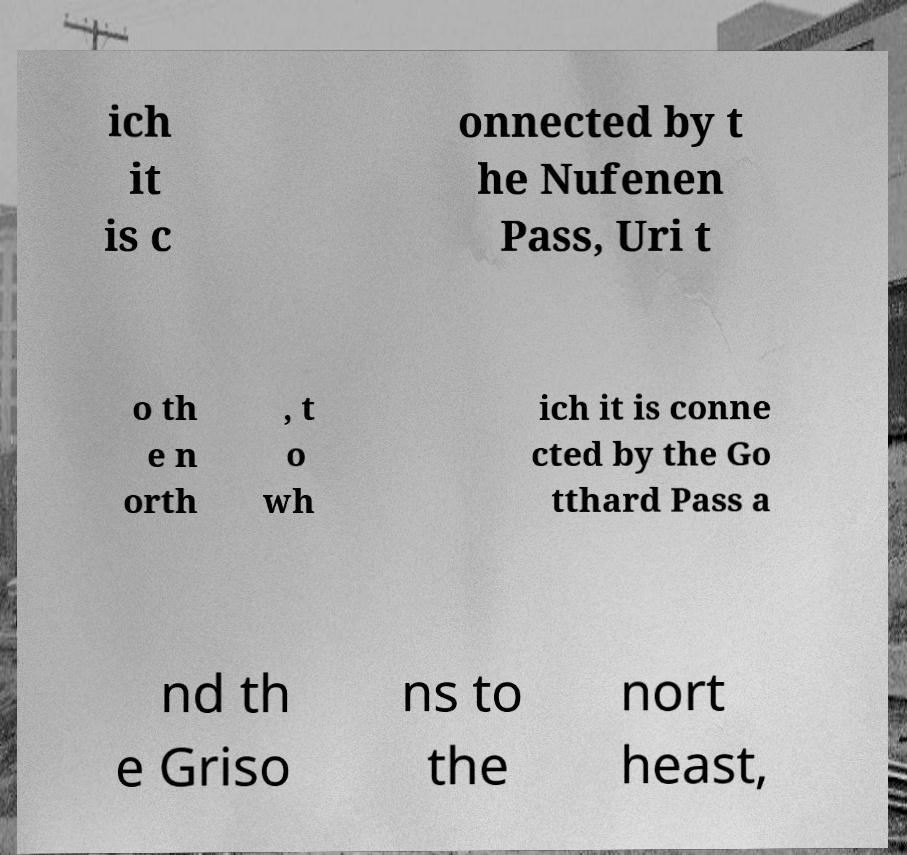Could you assist in decoding the text presented in this image and type it out clearly? ich it is c onnected by t he Nufenen Pass, Uri t o th e n orth , t o wh ich it is conne cted by the Go tthard Pass a nd th e Griso ns to the nort heast, 